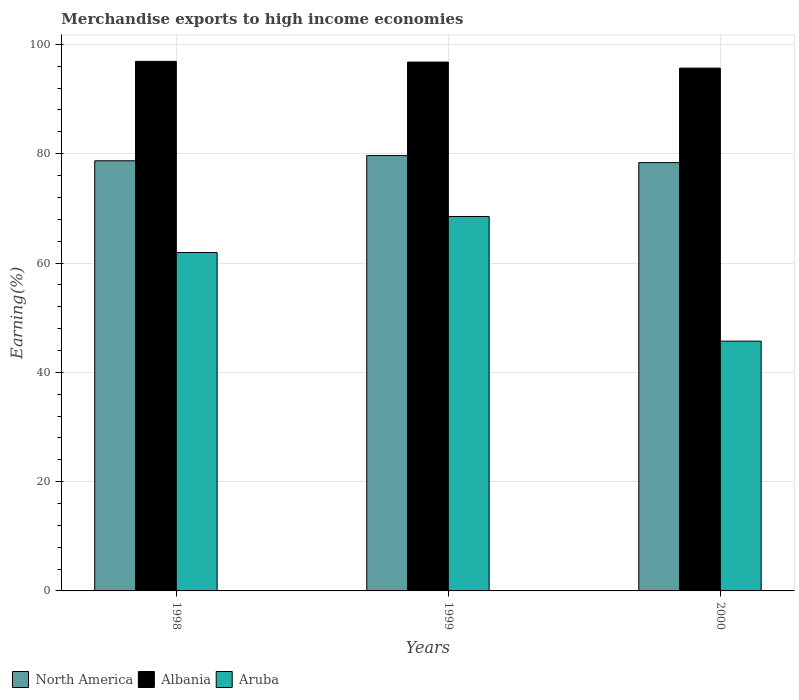How many groups of bars are there?
Your answer should be compact. 3. Are the number of bars per tick equal to the number of legend labels?
Provide a short and direct response. Yes. How many bars are there on the 3rd tick from the left?
Offer a very short reply. 3. What is the label of the 1st group of bars from the left?
Offer a very short reply. 1998. In how many cases, is the number of bars for a given year not equal to the number of legend labels?
Provide a succinct answer. 0. What is the percentage of amount earned from merchandise exports in North America in 1999?
Offer a terse response. 79.66. Across all years, what is the maximum percentage of amount earned from merchandise exports in North America?
Keep it short and to the point. 79.66. Across all years, what is the minimum percentage of amount earned from merchandise exports in Aruba?
Ensure brevity in your answer.  45.71. What is the total percentage of amount earned from merchandise exports in Aruba in the graph?
Make the answer very short. 176.14. What is the difference between the percentage of amount earned from merchandise exports in North America in 1999 and that in 2000?
Your response must be concise. 1.29. What is the difference between the percentage of amount earned from merchandise exports in Albania in 2000 and the percentage of amount earned from merchandise exports in North America in 1998?
Give a very brief answer. 16.96. What is the average percentage of amount earned from merchandise exports in North America per year?
Give a very brief answer. 78.91. In the year 1999, what is the difference between the percentage of amount earned from merchandise exports in North America and percentage of amount earned from merchandise exports in Aruba?
Offer a terse response. 11.15. In how many years, is the percentage of amount earned from merchandise exports in North America greater than 24 %?
Keep it short and to the point. 3. What is the ratio of the percentage of amount earned from merchandise exports in Albania in 1998 to that in 1999?
Offer a terse response. 1. Is the percentage of amount earned from merchandise exports in North America in 1998 less than that in 2000?
Ensure brevity in your answer.  No. Is the difference between the percentage of amount earned from merchandise exports in North America in 1998 and 2000 greater than the difference between the percentage of amount earned from merchandise exports in Aruba in 1998 and 2000?
Ensure brevity in your answer.  No. What is the difference between the highest and the second highest percentage of amount earned from merchandise exports in Albania?
Offer a terse response. 0.13. What is the difference between the highest and the lowest percentage of amount earned from merchandise exports in Albania?
Your answer should be very brief. 1.24. Is the sum of the percentage of amount earned from merchandise exports in Aruba in 1998 and 2000 greater than the maximum percentage of amount earned from merchandise exports in North America across all years?
Provide a short and direct response. Yes. What does the 3rd bar from the left in 2000 represents?
Keep it short and to the point. Aruba. What does the 3rd bar from the right in 1998 represents?
Provide a short and direct response. North America. How many bars are there?
Make the answer very short. 9. How many years are there in the graph?
Your answer should be compact. 3. What is the difference between two consecutive major ticks on the Y-axis?
Ensure brevity in your answer.  20. Does the graph contain any zero values?
Make the answer very short. No. Does the graph contain grids?
Provide a succinct answer. Yes. Where does the legend appear in the graph?
Provide a short and direct response. Bottom left. How are the legend labels stacked?
Provide a succinct answer. Horizontal. What is the title of the graph?
Ensure brevity in your answer.  Merchandise exports to high income economies. What is the label or title of the Y-axis?
Offer a very short reply. Earning(%). What is the Earning(%) of North America in 1998?
Make the answer very short. 78.71. What is the Earning(%) of Albania in 1998?
Your answer should be compact. 96.9. What is the Earning(%) in Aruba in 1998?
Keep it short and to the point. 61.92. What is the Earning(%) of North America in 1999?
Your answer should be compact. 79.66. What is the Earning(%) in Albania in 1999?
Ensure brevity in your answer.  96.77. What is the Earning(%) of Aruba in 1999?
Your response must be concise. 68.51. What is the Earning(%) of North America in 2000?
Offer a terse response. 78.37. What is the Earning(%) in Albania in 2000?
Provide a short and direct response. 95.66. What is the Earning(%) of Aruba in 2000?
Provide a succinct answer. 45.71. Across all years, what is the maximum Earning(%) of North America?
Provide a short and direct response. 79.66. Across all years, what is the maximum Earning(%) of Albania?
Provide a succinct answer. 96.9. Across all years, what is the maximum Earning(%) in Aruba?
Your answer should be very brief. 68.51. Across all years, what is the minimum Earning(%) in North America?
Your response must be concise. 78.37. Across all years, what is the minimum Earning(%) of Albania?
Provide a succinct answer. 95.66. Across all years, what is the minimum Earning(%) of Aruba?
Provide a succinct answer. 45.71. What is the total Earning(%) of North America in the graph?
Offer a terse response. 236.74. What is the total Earning(%) in Albania in the graph?
Provide a succinct answer. 289.33. What is the total Earning(%) of Aruba in the graph?
Your answer should be very brief. 176.14. What is the difference between the Earning(%) in North America in 1998 and that in 1999?
Provide a short and direct response. -0.96. What is the difference between the Earning(%) of Albania in 1998 and that in 1999?
Your answer should be compact. 0.13. What is the difference between the Earning(%) in Aruba in 1998 and that in 1999?
Give a very brief answer. -6.59. What is the difference between the Earning(%) in North America in 1998 and that in 2000?
Provide a short and direct response. 0.34. What is the difference between the Earning(%) of Albania in 1998 and that in 2000?
Your response must be concise. 1.24. What is the difference between the Earning(%) of Aruba in 1998 and that in 2000?
Your answer should be very brief. 16.22. What is the difference between the Earning(%) in North America in 1999 and that in 2000?
Offer a very short reply. 1.29. What is the difference between the Earning(%) in Albania in 1999 and that in 2000?
Provide a short and direct response. 1.11. What is the difference between the Earning(%) in Aruba in 1999 and that in 2000?
Keep it short and to the point. 22.81. What is the difference between the Earning(%) of North America in 1998 and the Earning(%) of Albania in 1999?
Your answer should be compact. -18.06. What is the difference between the Earning(%) in North America in 1998 and the Earning(%) in Aruba in 1999?
Keep it short and to the point. 10.2. What is the difference between the Earning(%) of Albania in 1998 and the Earning(%) of Aruba in 1999?
Offer a very short reply. 28.39. What is the difference between the Earning(%) of North America in 1998 and the Earning(%) of Albania in 2000?
Your answer should be compact. -16.96. What is the difference between the Earning(%) in North America in 1998 and the Earning(%) in Aruba in 2000?
Provide a succinct answer. 33. What is the difference between the Earning(%) of Albania in 1998 and the Earning(%) of Aruba in 2000?
Give a very brief answer. 51.19. What is the difference between the Earning(%) in North America in 1999 and the Earning(%) in Albania in 2000?
Make the answer very short. -16. What is the difference between the Earning(%) in North America in 1999 and the Earning(%) in Aruba in 2000?
Keep it short and to the point. 33.96. What is the difference between the Earning(%) of Albania in 1999 and the Earning(%) of Aruba in 2000?
Your response must be concise. 51.06. What is the average Earning(%) of North America per year?
Give a very brief answer. 78.91. What is the average Earning(%) of Albania per year?
Your answer should be compact. 96.44. What is the average Earning(%) of Aruba per year?
Offer a very short reply. 58.71. In the year 1998, what is the difference between the Earning(%) in North America and Earning(%) in Albania?
Your answer should be very brief. -18.19. In the year 1998, what is the difference between the Earning(%) in North America and Earning(%) in Aruba?
Give a very brief answer. 16.79. In the year 1998, what is the difference between the Earning(%) in Albania and Earning(%) in Aruba?
Give a very brief answer. 34.98. In the year 1999, what is the difference between the Earning(%) of North America and Earning(%) of Albania?
Your answer should be compact. -17.11. In the year 1999, what is the difference between the Earning(%) in North America and Earning(%) in Aruba?
Ensure brevity in your answer.  11.15. In the year 1999, what is the difference between the Earning(%) in Albania and Earning(%) in Aruba?
Provide a succinct answer. 28.26. In the year 2000, what is the difference between the Earning(%) in North America and Earning(%) in Albania?
Ensure brevity in your answer.  -17.29. In the year 2000, what is the difference between the Earning(%) of North America and Earning(%) of Aruba?
Offer a terse response. 32.66. In the year 2000, what is the difference between the Earning(%) in Albania and Earning(%) in Aruba?
Provide a succinct answer. 49.96. What is the ratio of the Earning(%) of Aruba in 1998 to that in 1999?
Your answer should be compact. 0.9. What is the ratio of the Earning(%) of North America in 1998 to that in 2000?
Your answer should be very brief. 1. What is the ratio of the Earning(%) in Albania in 1998 to that in 2000?
Ensure brevity in your answer.  1.01. What is the ratio of the Earning(%) in Aruba in 1998 to that in 2000?
Offer a very short reply. 1.35. What is the ratio of the Earning(%) of North America in 1999 to that in 2000?
Provide a short and direct response. 1.02. What is the ratio of the Earning(%) of Albania in 1999 to that in 2000?
Give a very brief answer. 1.01. What is the ratio of the Earning(%) of Aruba in 1999 to that in 2000?
Your answer should be very brief. 1.5. What is the difference between the highest and the second highest Earning(%) in North America?
Your response must be concise. 0.96. What is the difference between the highest and the second highest Earning(%) in Albania?
Your answer should be compact. 0.13. What is the difference between the highest and the second highest Earning(%) in Aruba?
Provide a short and direct response. 6.59. What is the difference between the highest and the lowest Earning(%) in North America?
Ensure brevity in your answer.  1.29. What is the difference between the highest and the lowest Earning(%) in Albania?
Provide a succinct answer. 1.24. What is the difference between the highest and the lowest Earning(%) of Aruba?
Offer a very short reply. 22.81. 